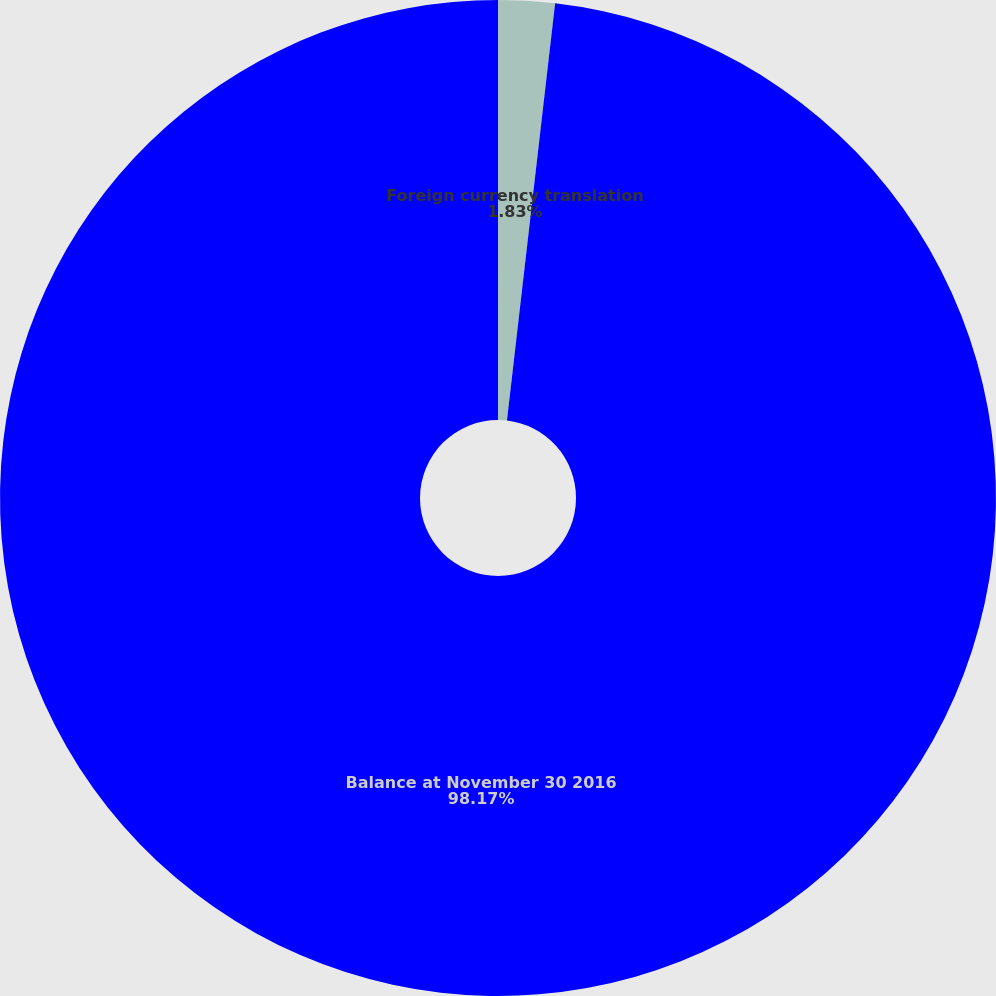<chart> <loc_0><loc_0><loc_500><loc_500><pie_chart><fcel>Foreign currency translation<fcel>Balance at November 30 2016<nl><fcel>1.83%<fcel>98.17%<nl></chart> 